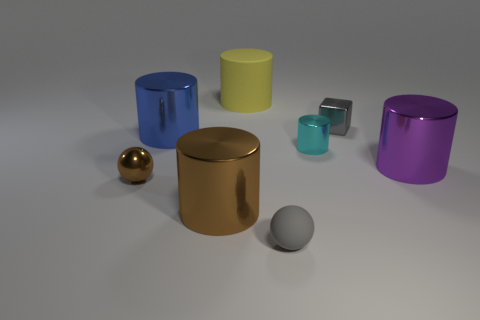Are there any other things that are the same shape as the small gray metal object?
Offer a very short reply. No. How many large yellow things have the same material as the small cyan cylinder?
Offer a terse response. 0. Do the brown metallic object behind the brown shiny cylinder and the rubber object in front of the large purple thing have the same size?
Make the answer very short. Yes. What is the color of the sphere in front of the big object that is in front of the large cylinder that is to the right of the tiny gray shiny block?
Provide a succinct answer. Gray. Is there another big object of the same shape as the blue metal thing?
Give a very brief answer. Yes. Is the number of small shiny blocks on the left side of the big brown shiny object the same as the number of gray spheres behind the tiny gray matte thing?
Offer a very short reply. Yes. Do the matte thing that is behind the small cyan shiny thing and the big purple metal thing have the same shape?
Give a very brief answer. Yes. Do the large blue metal thing and the tiny gray matte thing have the same shape?
Make the answer very short. No. What number of rubber objects are either spheres or cylinders?
Your response must be concise. 2. There is a tiny thing that is the same color as the tiny metallic cube; what is it made of?
Offer a very short reply. Rubber. 